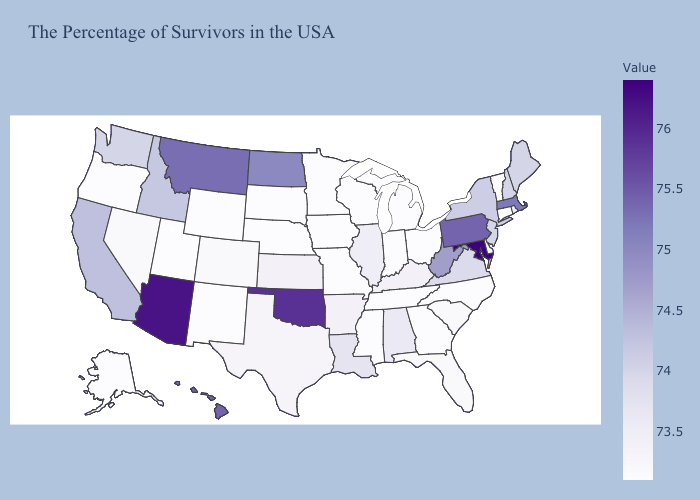Does Kentucky have a lower value than West Virginia?
Concise answer only. Yes. Among the states that border Maryland , does Pennsylvania have the highest value?
Be succinct. Yes. Which states have the lowest value in the USA?
Be succinct. Vermont, Connecticut, Delaware, North Carolina, Ohio, Georgia, Michigan, Indiana, Tennessee, Wisconsin, Mississippi, Missouri, Minnesota, Iowa, Nebraska, South Dakota, Wyoming, New Mexico, Utah, Oregon, Alaska. 